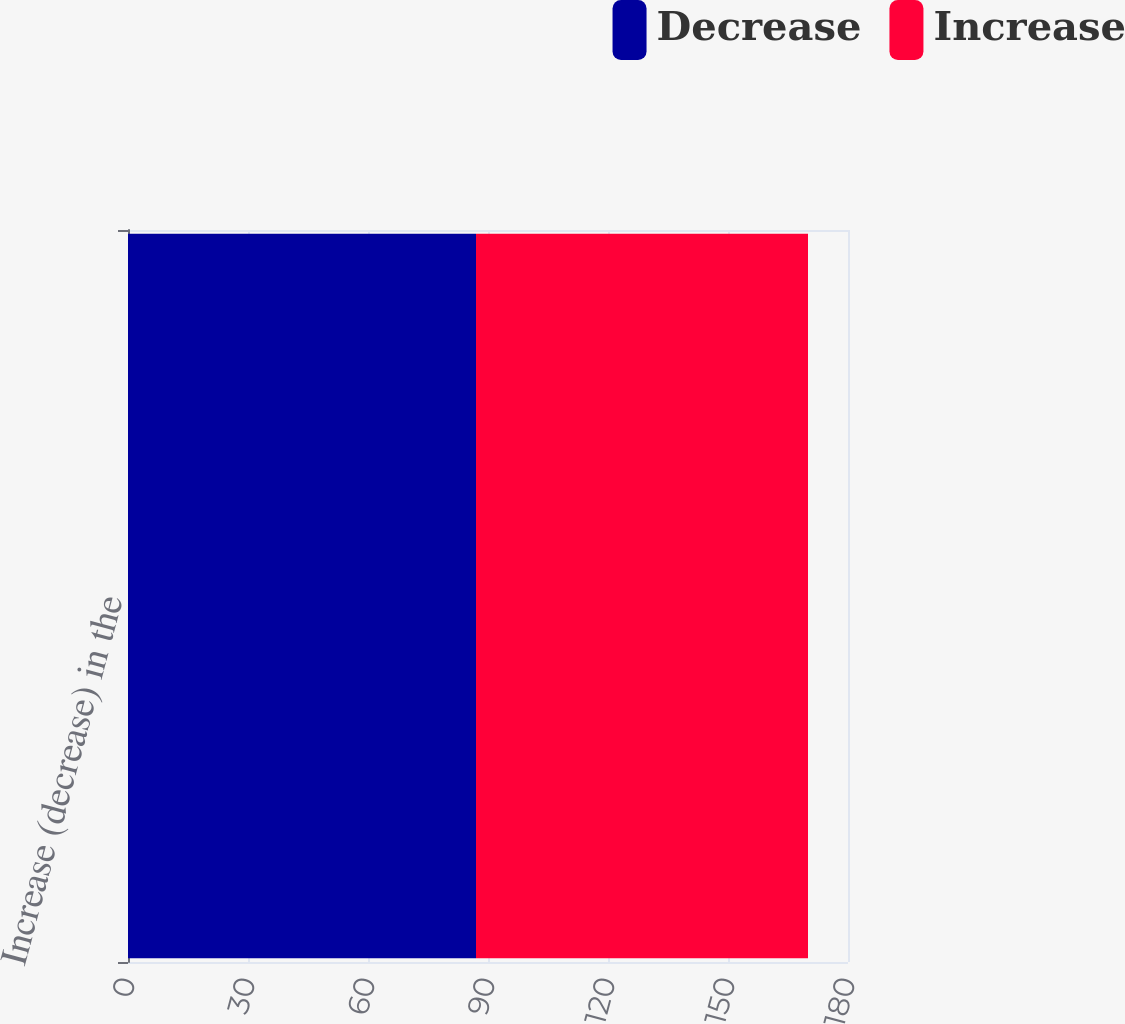Convert chart. <chart><loc_0><loc_0><loc_500><loc_500><stacked_bar_chart><ecel><fcel>Increase (decrease) in the<nl><fcel>Decrease<fcel>87<nl><fcel>Increase<fcel>83<nl></chart> 